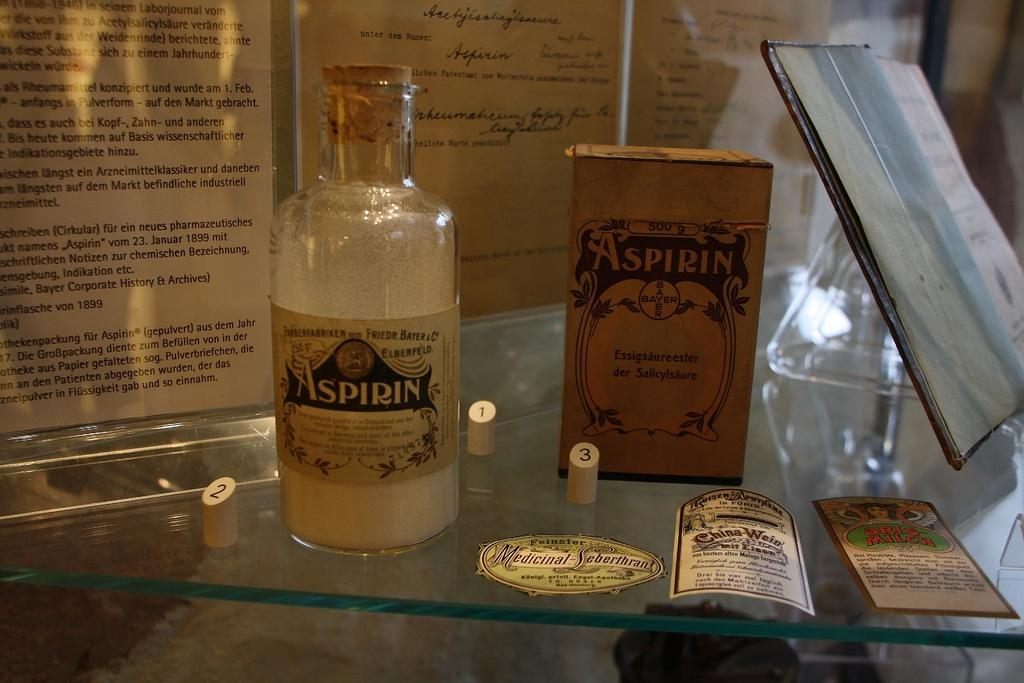What object can be seen in the image that is typically used for holding liquids? There is a bottle in the image. What is the other object in the image that is typically used for storage? There is a box in the image. What is written on the box? The box has "Aspirin" written on it. What can be seen in the background of the image? There are papers and a photo frame in the background of the image. Can you see any mountains in the background of the image? There are no mountains visible in the background of the image. What type of fruit is being used as a chess piece in the image? There is no fruit or chess game present in the image. 